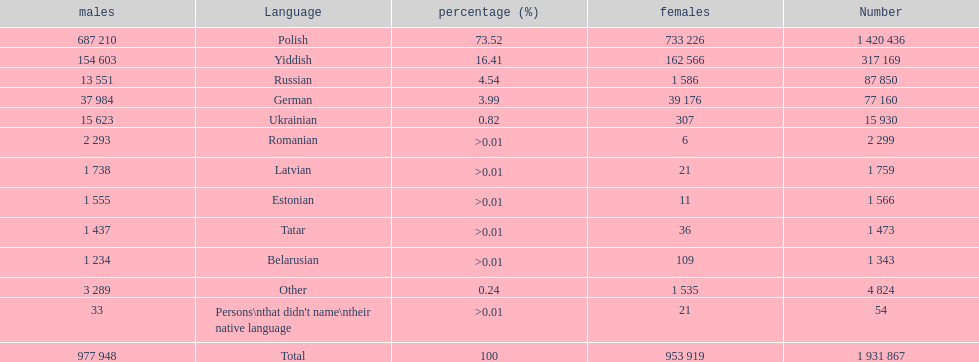Number of male russian speakers 13 551. 